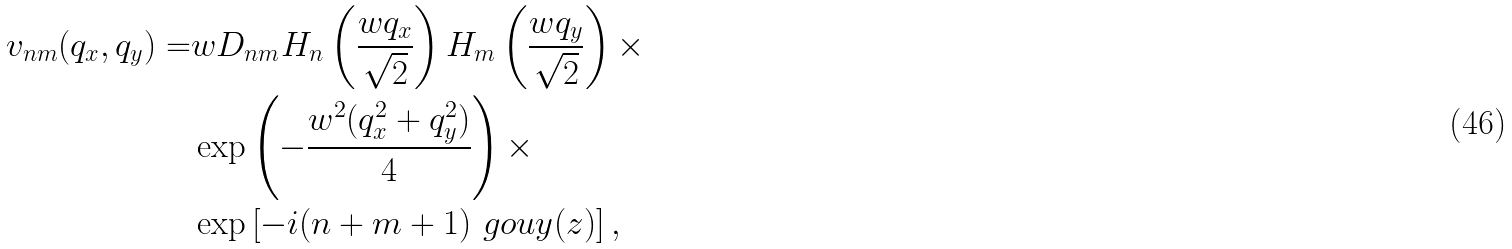<formula> <loc_0><loc_0><loc_500><loc_500>v _ { n m } ( q _ { x } , q _ { y } ) = & w D _ { n m } H _ { n } \left ( \frac { w q _ { x } } { \sqrt { 2 } } \right ) H _ { m } \left ( \frac { w q _ { y } } { \sqrt { 2 } } \right ) \times \\ & \exp \left ( - \frac { w ^ { 2 } ( q _ { x } ^ { 2 } + q _ { y } ^ { 2 } ) } { 4 } \right ) \times \\ & \exp \left [ - i ( n + m + 1 ) \ g o u y ( z ) \right ] ,</formula> 